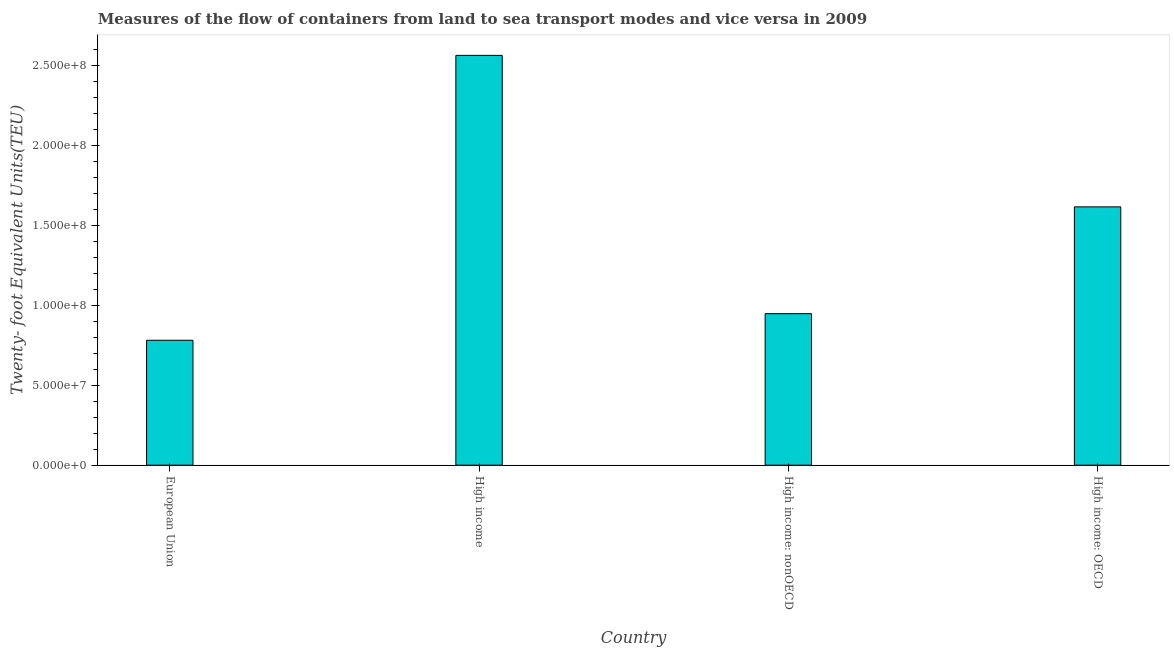What is the title of the graph?
Make the answer very short. Measures of the flow of containers from land to sea transport modes and vice versa in 2009. What is the label or title of the Y-axis?
Ensure brevity in your answer.  Twenty- foot Equivalent Units(TEU). What is the container port traffic in High income: nonOECD?
Provide a succinct answer. 9.48e+07. Across all countries, what is the maximum container port traffic?
Provide a short and direct response. 2.57e+08. Across all countries, what is the minimum container port traffic?
Give a very brief answer. 7.82e+07. In which country was the container port traffic maximum?
Ensure brevity in your answer.  High income. In which country was the container port traffic minimum?
Make the answer very short. European Union. What is the sum of the container port traffic?
Give a very brief answer. 5.91e+08. What is the difference between the container port traffic in European Union and High income: OECD?
Your answer should be compact. -8.35e+07. What is the average container port traffic per country?
Your answer should be very brief. 1.48e+08. What is the median container port traffic?
Provide a short and direct response. 1.28e+08. What is the ratio of the container port traffic in High income: OECD to that in High income: nonOECD?
Offer a very short reply. 1.71. Is the difference between the container port traffic in High income and High income: OECD greater than the difference between any two countries?
Your answer should be very brief. No. What is the difference between the highest and the second highest container port traffic?
Keep it short and to the point. 9.48e+07. What is the difference between the highest and the lowest container port traffic?
Give a very brief answer. 1.78e+08. How many bars are there?
Your response must be concise. 4. Are all the bars in the graph horizontal?
Your answer should be very brief. No. How many countries are there in the graph?
Provide a succinct answer. 4. What is the Twenty- foot Equivalent Units(TEU) of European Union?
Offer a terse response. 7.82e+07. What is the Twenty- foot Equivalent Units(TEU) of High income?
Your answer should be compact. 2.57e+08. What is the Twenty- foot Equivalent Units(TEU) in High income: nonOECD?
Your response must be concise. 9.48e+07. What is the Twenty- foot Equivalent Units(TEU) of High income: OECD?
Make the answer very short. 1.62e+08. What is the difference between the Twenty- foot Equivalent Units(TEU) in European Union and High income?
Offer a terse response. -1.78e+08. What is the difference between the Twenty- foot Equivalent Units(TEU) in European Union and High income: nonOECD?
Provide a succinct answer. -1.66e+07. What is the difference between the Twenty- foot Equivalent Units(TEU) in European Union and High income: OECD?
Give a very brief answer. -8.35e+07. What is the difference between the Twenty- foot Equivalent Units(TEU) in High income and High income: nonOECD?
Your answer should be compact. 1.62e+08. What is the difference between the Twenty- foot Equivalent Units(TEU) in High income and High income: OECD?
Offer a terse response. 9.48e+07. What is the difference between the Twenty- foot Equivalent Units(TEU) in High income: nonOECD and High income: OECD?
Your answer should be very brief. -6.69e+07. What is the ratio of the Twenty- foot Equivalent Units(TEU) in European Union to that in High income?
Your answer should be compact. 0.3. What is the ratio of the Twenty- foot Equivalent Units(TEU) in European Union to that in High income: nonOECD?
Offer a very short reply. 0.82. What is the ratio of the Twenty- foot Equivalent Units(TEU) in European Union to that in High income: OECD?
Your response must be concise. 0.48. What is the ratio of the Twenty- foot Equivalent Units(TEU) in High income to that in High income: nonOECD?
Offer a very short reply. 2.71. What is the ratio of the Twenty- foot Equivalent Units(TEU) in High income to that in High income: OECD?
Your response must be concise. 1.59. What is the ratio of the Twenty- foot Equivalent Units(TEU) in High income: nonOECD to that in High income: OECD?
Provide a succinct answer. 0.59. 